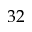<formula> <loc_0><loc_0><loc_500><loc_500>3 2</formula> 